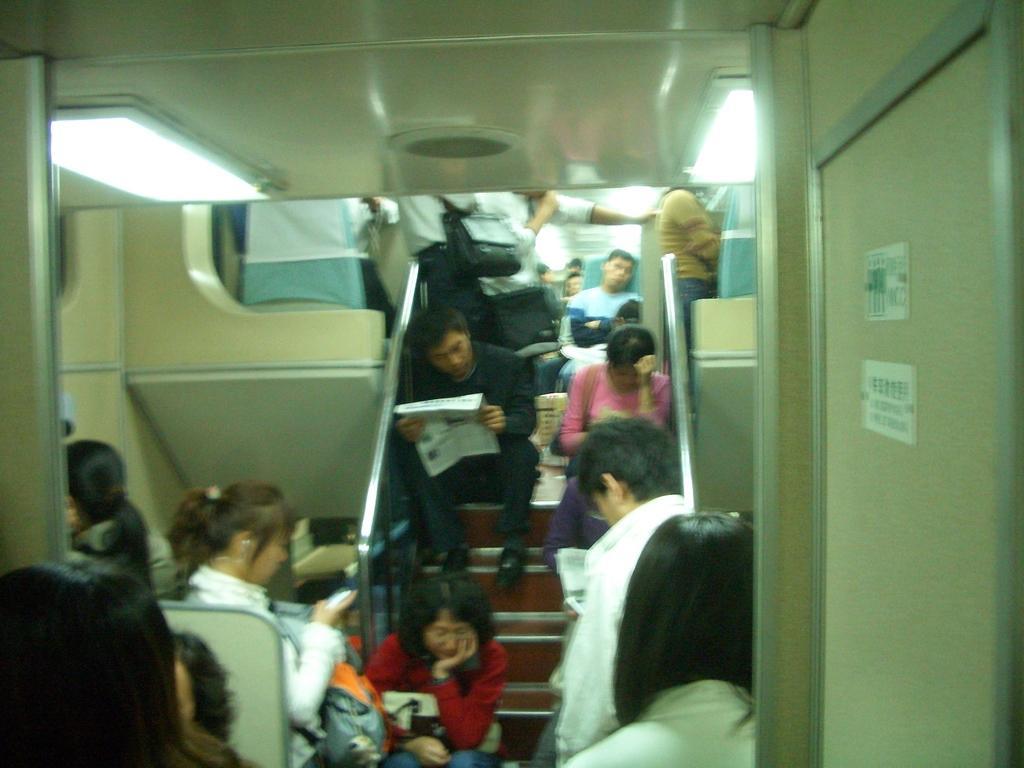Could you give a brief overview of what you see in this image? In this picture there are 8 people sitting on the stairs, one man is reading newspaper. Beside him there is a woman carrying a bag. Before him there is a woman at the bottom, she is holding a bag towards the left there is a woman in white shirt and she is holding a mobile. Towards the right there is a wall. On the top, there are two lights. 